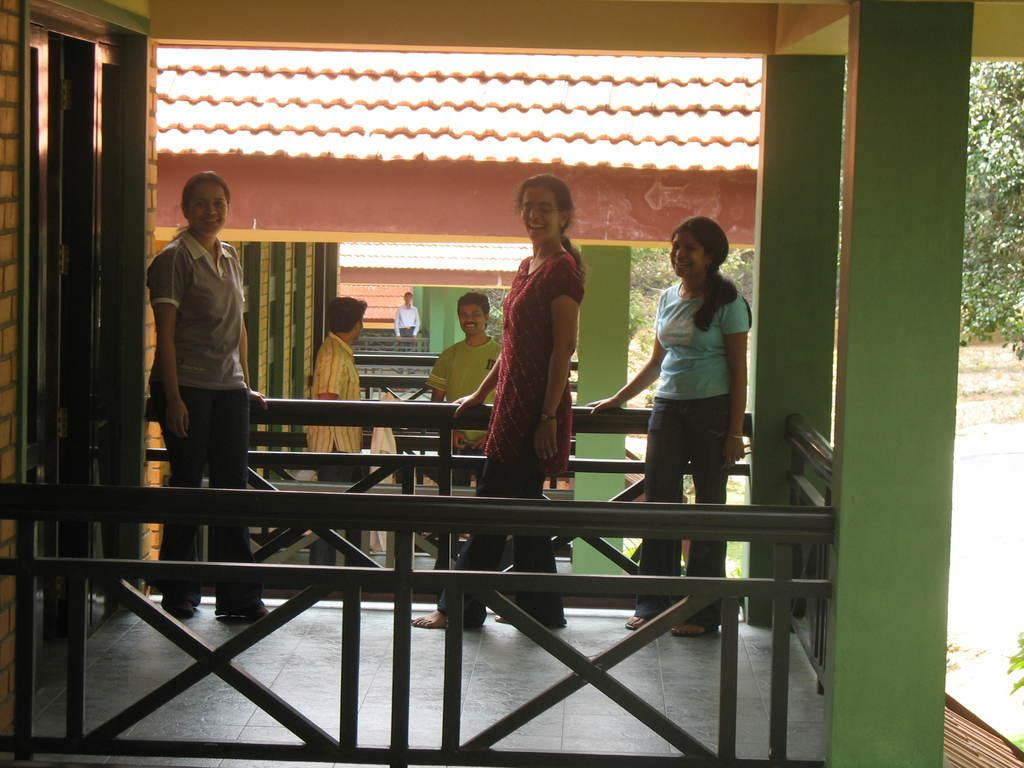What can be seen in the image involving people? There are people standing in the image. What architectural features are present in the image? There are railings and pillars in the image. What type of structures can be seen in the image? There are houses in the image. What can be seen in the background of the image? Leaves are visible in the background of the image. What type of button can be seen on the goose in the image? There is no goose or button present in the image. What is the goose drinking from in the image? There is no goose or bottle present in the image. 